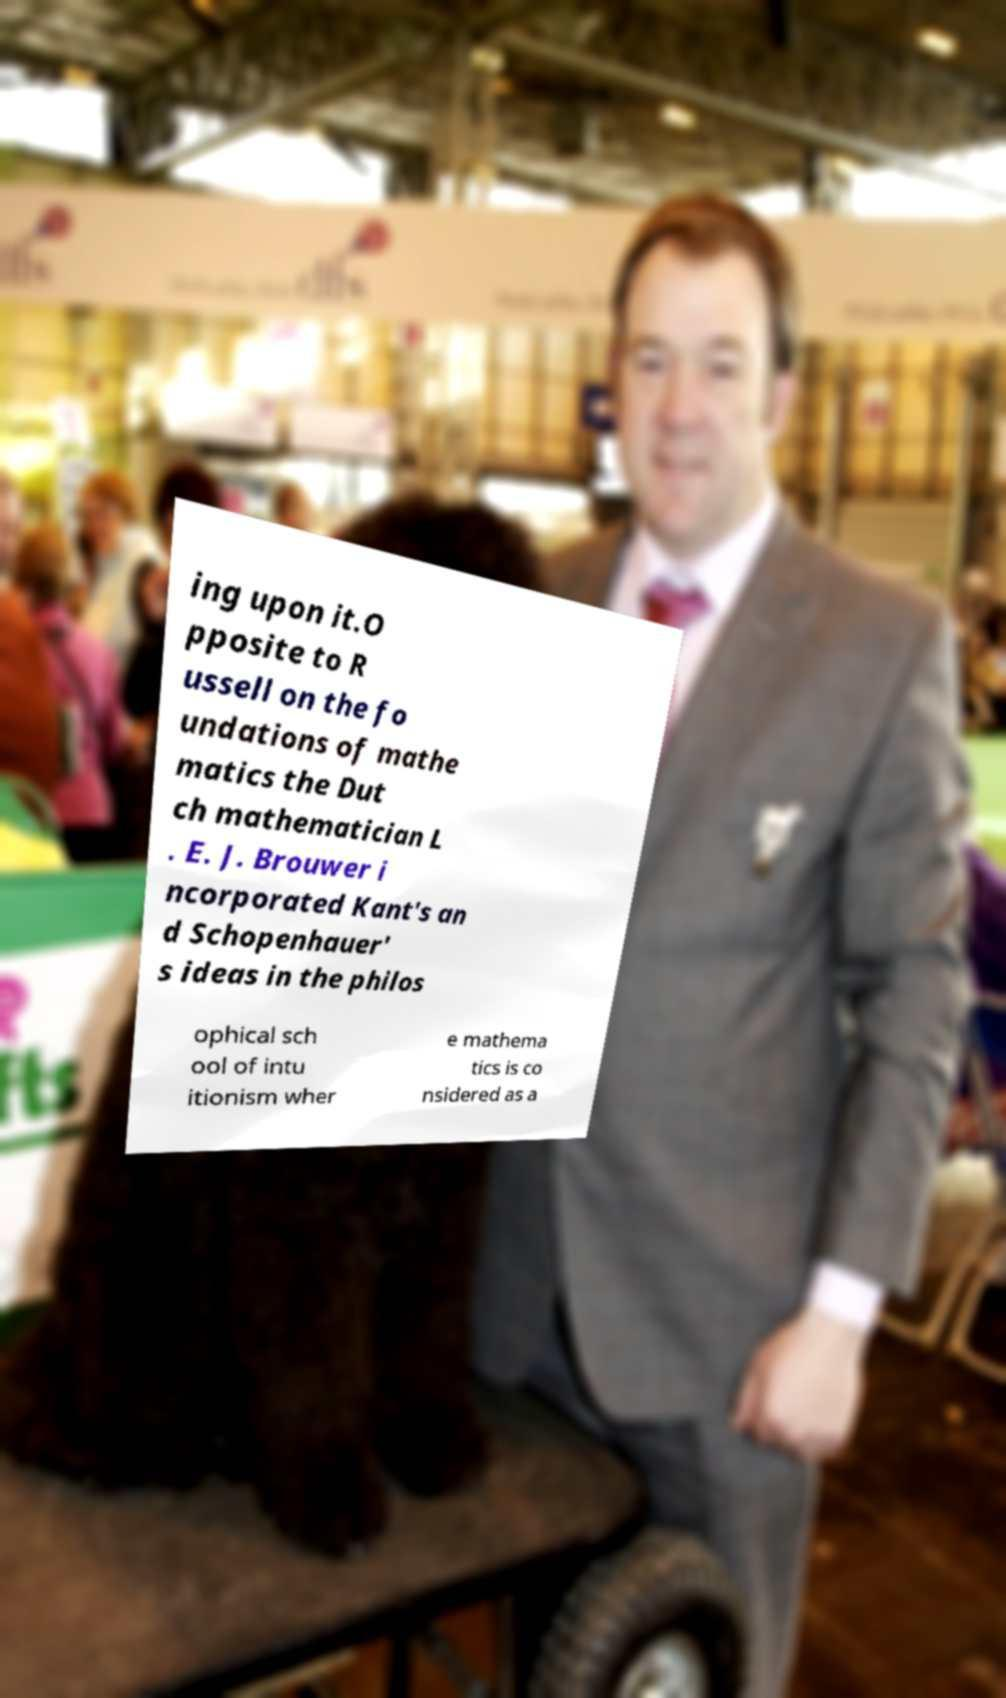I need the written content from this picture converted into text. Can you do that? ing upon it.O pposite to R ussell on the fo undations of mathe matics the Dut ch mathematician L . E. J. Brouwer i ncorporated Kant's an d Schopenhauer' s ideas in the philos ophical sch ool of intu itionism wher e mathema tics is co nsidered as a 